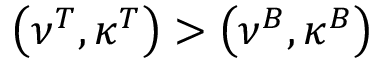<formula> <loc_0><loc_0><loc_500><loc_500>\left ( \nu ^ { T } , \kappa ^ { T } \right ) > \left ( \nu ^ { B } , \kappa ^ { B } \right )</formula> 